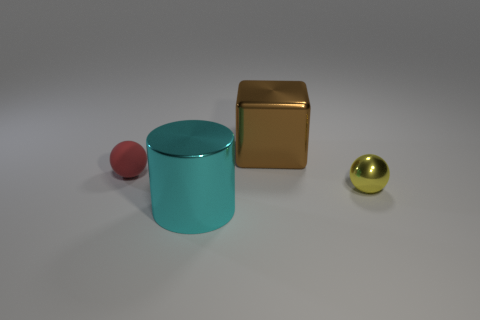Can you describe the lighting in the scene? The lighting in the scene appears to be coming from above, casting soft shadows directly under the objects, consistent with a diffuse or ambient light source. 